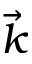<formula> <loc_0><loc_0><loc_500><loc_500>\vec { k }</formula> 